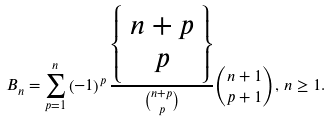Convert formula to latex. <formula><loc_0><loc_0><loc_500><loc_500>B _ { n } = \sum _ { p = 1 } ^ { n } \left ( - 1 \right ) ^ { p } \frac { \left \{ \begin{array} { c } n + p \\ p \end{array} \right \} } { \binom { n + p } { p } } \binom { n + 1 } { p + 1 } , \, n \geq 1 .</formula> 